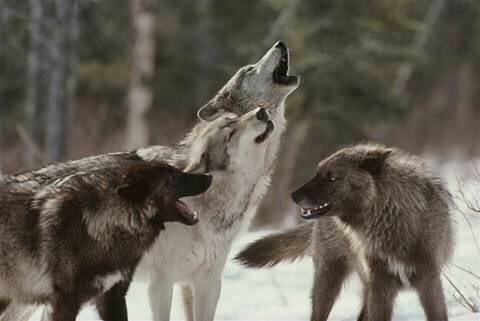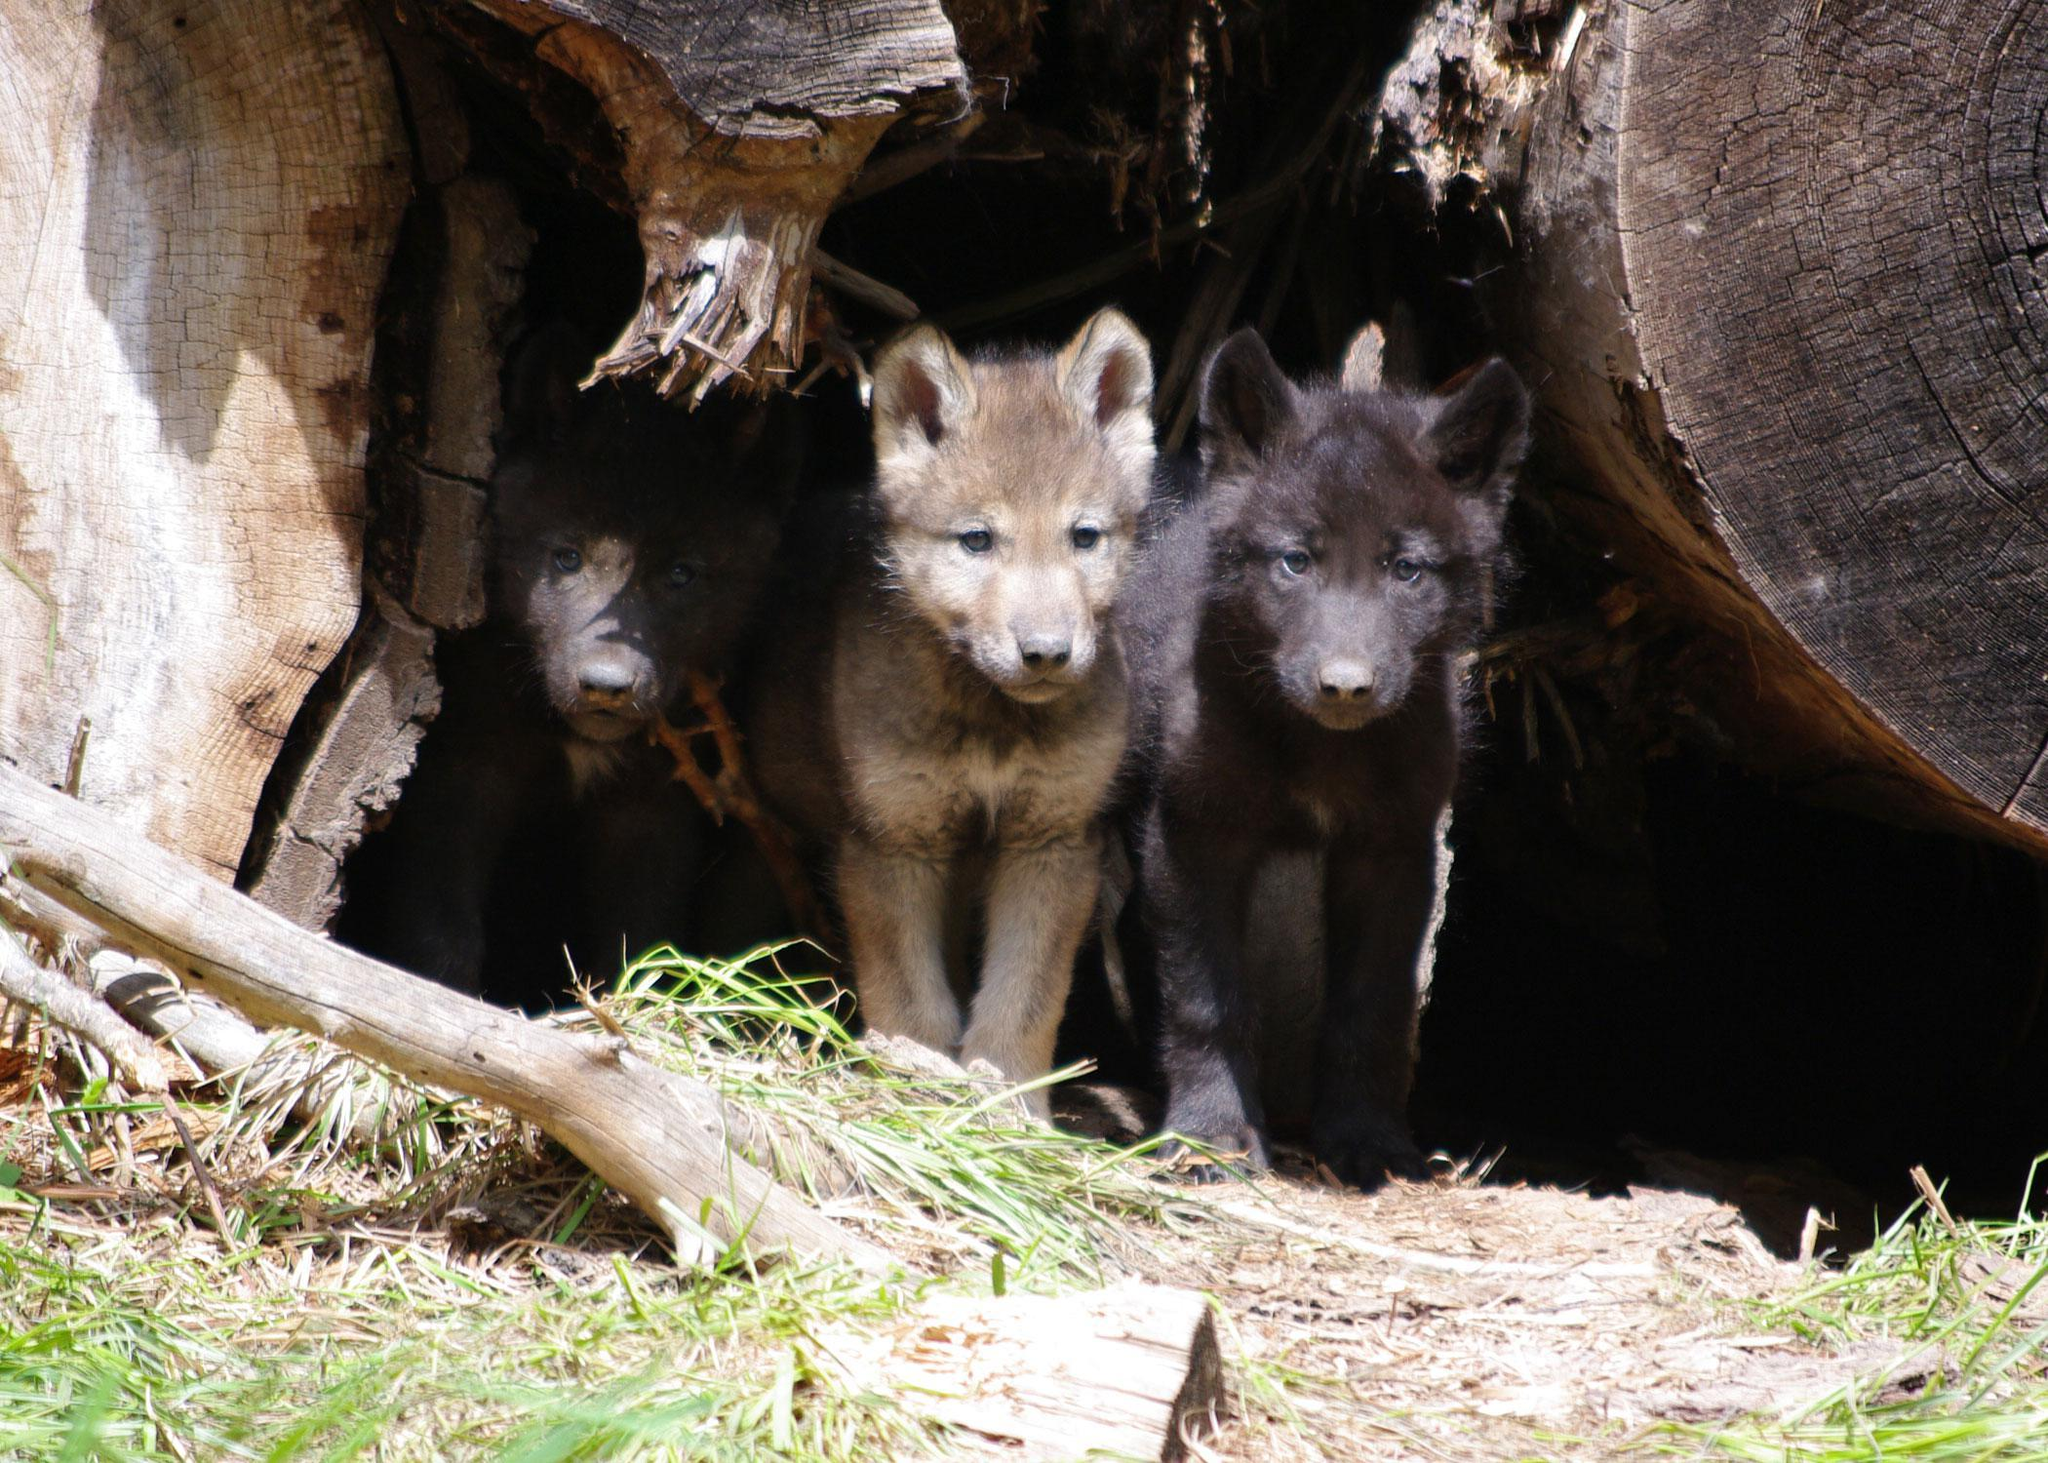The first image is the image on the left, the second image is the image on the right. Evaluate the accuracy of this statement regarding the images: "At least one wolf has its mouth open.". Is it true? Answer yes or no. Yes. 